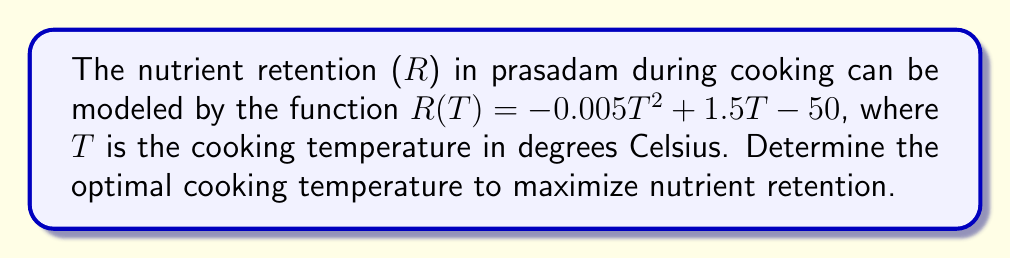Teach me how to tackle this problem. To find the optimal temperature for maximum nutrient retention, we need to find the maximum point of the given function. This can be done using derivatives:

1. Start with the given function:
   $R(T) = -0.005T^2 + 1.5T - 50$

2. Find the first derivative:
   $R'(T) = -0.01T + 1.5$

3. Set the first derivative equal to zero to find critical points:
   $-0.01T + 1.5 = 0$
   $-0.01T = -1.5$
   $T = 150$

4. To confirm this is a maximum, check the second derivative:
   $R''(T) = -0.01$

   Since $R''(T)$ is negative, the critical point is a maximum.

5. Calculate the maximum nutrient retention:
   $R(150) = -0.005(150)^2 + 1.5(150) - 50$
   $= -112.5 + 225 - 50$
   $= 62.5$

Therefore, the optimal cooking temperature for maximum nutrient retention is 150°C, resulting in a retention value of 62.5.
Answer: 150°C 